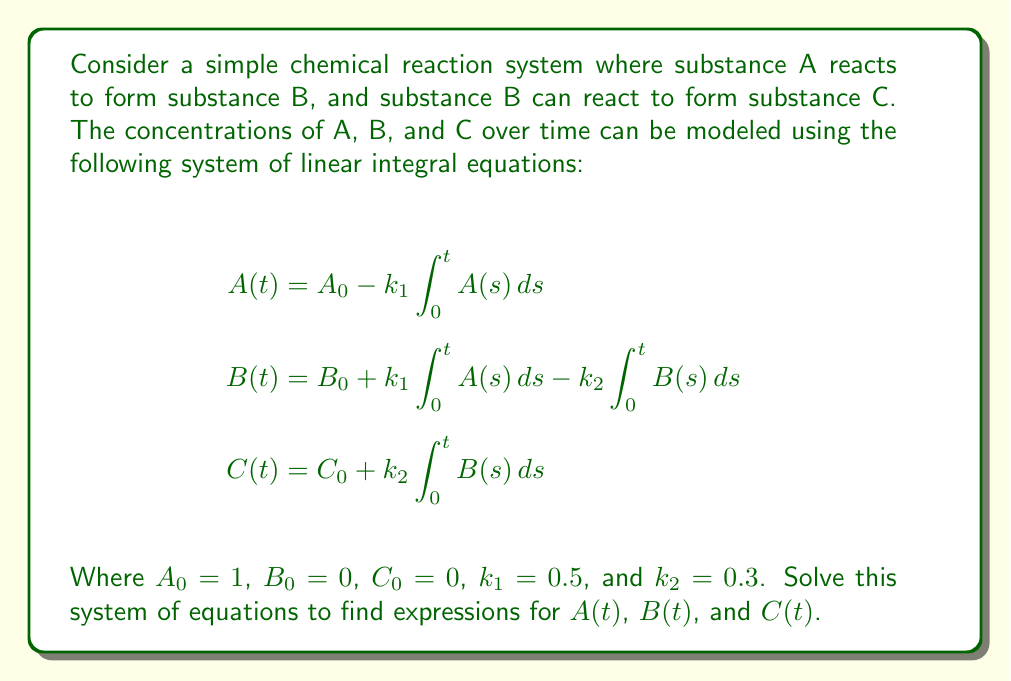Can you solve this math problem? Let's solve this system of linear integral equations step by step:

1) First, we'll differentiate both sides of each equation with respect to t:

   $$\begin{align}
   \frac{dA}{dt} &= -k_1 A(t) \\
   \frac{dB}{dt} &= k_1 A(t) - k_2 B(t) \\
   \frac{dC}{dt} &= k_2 B(t)
   \end{align}$$

2) Now we have a system of ordinary differential equations. Let's solve for A(t) first:

   $$\frac{dA}{dt} = -k_1 A(t)$$
   
   This is a separable equation. Solving it:
   
   $$A(t) = A_0 e^{-k_1 t} = e^{-0.5t}$$

3) Now we can substitute this into the equation for B(t):

   $$\frac{dB}{dt} + k_2 B = k_1 A_0 e^{-k_1 t}$$

   This is a linear first-order ODE. The solution is:

   $$B(t) = \frac{k_1 A_0}{k_2 - k_1}(e^{-k_1 t} - e^{-k_2 t}) = \frac{0.5}{0.3 - 0.5}(e^{-0.5t} - e^{-0.3t}) = 2.5(e^{-0.3t} - e^{-0.5t})$$

4) Finally, we can solve for C(t) by integrating the last equation:

   $$C(t) = C_0 + k_2 \int_0^t B(s) ds$$

   $$C(t) = 0 + 0.3 \int_0^t 2.5(e^{-0.3s} - e^{-0.5s}) ds$$

   $$C(t) = 0.75 \int_0^t (e^{-0.3s} - e^{-0.5s}) ds$$

   $$C(t) = 0.75 \left[-\frac{1}{0.3}e^{-0.3s} + \frac{1}{0.5}e^{-0.5s}\right]_0^t$$

   $$C(t) = 0.75 \left[-\frac{1}{0.3}e^{-0.3t} + \frac{1}{0.5}e^{-0.5t} + \frac{1}{0.3} - \frac{1}{0.5}\right]$$

   $$C(t) = 1 - e^{-0.3t} - 1.5e^{-0.5t} + 0.5$$

   $$C(t) = 1.5 - e^{-0.3t} - 1.5e^{-0.5t}$$

Thus, we have solved the system of linear integral equations.
Answer: $A(t) = e^{-0.5t}$, $B(t) = 2.5(e^{-0.3t} - e^{-0.5t})$, $C(t) = 1.5 - e^{-0.3t} - 1.5e^{-0.5t}$ 